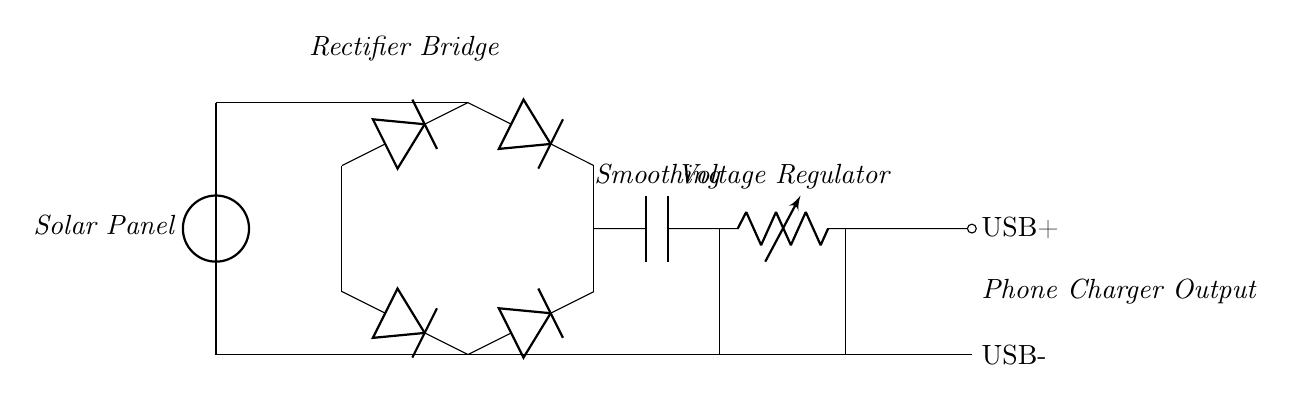What type of power source does this circuit use? The circuit uses a solar panel as its power source, indicated by the labeled component at the start of the circuit.
Answer: solar panel What is the purpose of the diodes in this circuit? The diodes in the circuit form a bridge rectifier which converts alternating current to direct current, allowing the phone charger to operate correctly.
Answer: bridge rectifier How many diodes are in the circuit? There are four diodes shown in the bridge configuration, which is typical for a full-wave rectifier arrangement.
Answer: four What is the component labeled 'smoothing' used for? The 'smoothing' capacitor is used to reduce fluctuations in the voltage output, ensuring a more stable current supply for charging the phone.
Answer: reduce fluctuations What does the voltage regulator do? The voltage regulator ensures that the output voltage remains constant and suitable for charging a phone, regardless of variations in input voltage from the solar panel.
Answer: maintain constant voltage What type of output does this circuit provide for charging? The circuit provides a USB output, which is standard for charging phones and devices, as indicated by the label.
Answer: USB output 